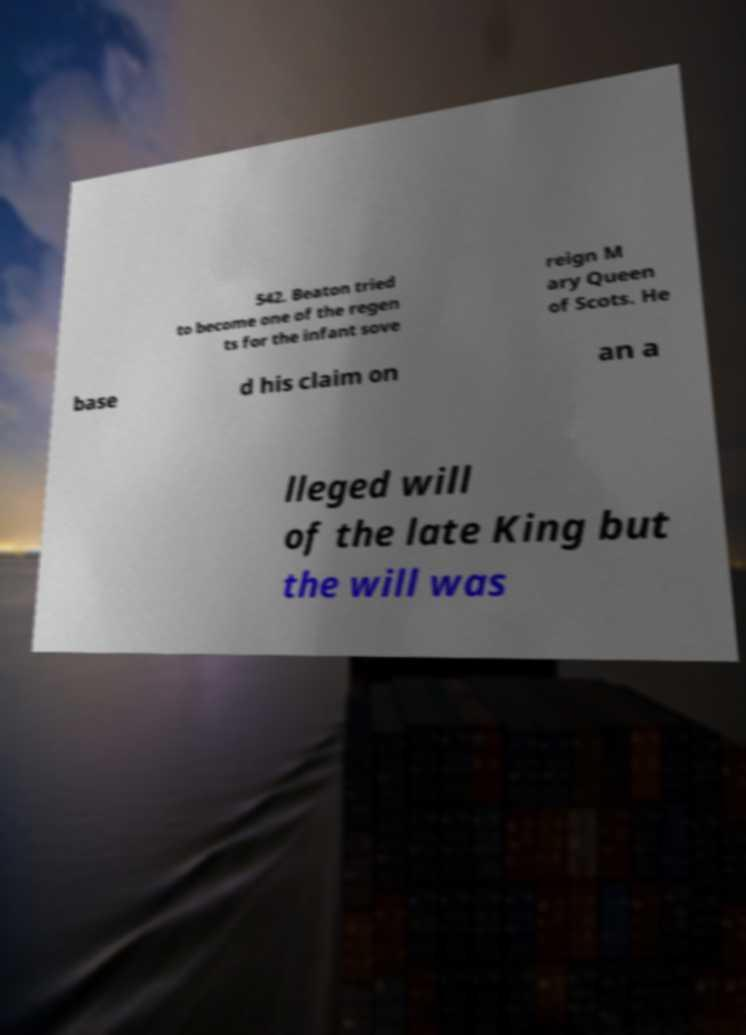Please identify and transcribe the text found in this image. 542. Beaton tried to become one of the regen ts for the infant sove reign M ary Queen of Scots. He base d his claim on an a lleged will of the late King but the will was 